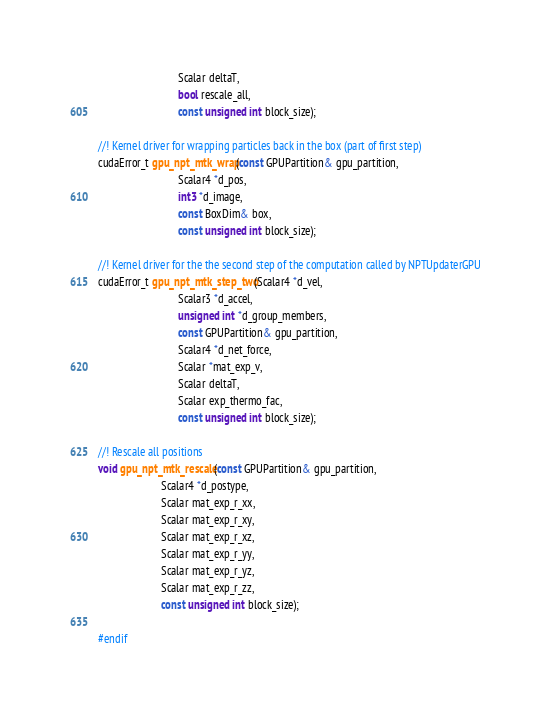<code> <loc_0><loc_0><loc_500><loc_500><_Cuda_>                             Scalar deltaT,
                             bool rescale_all,
                             const unsigned int block_size);

//! Kernel driver for wrapping particles back in the box (part of first step)
cudaError_t gpu_npt_mtk_wrap(const GPUPartition& gpu_partition,
                             Scalar4 *d_pos,
                             int3 *d_image,
                             const BoxDim& box,
                             const unsigned int block_size);

//! Kernel driver for the the second step of the computation called by NPTUpdaterGPU
cudaError_t gpu_npt_mtk_step_two(Scalar4 *d_vel,
                             Scalar3 *d_accel,
                             unsigned int *d_group_members,
                             const GPUPartition& gpu_partition,
                             Scalar4 *d_net_force,
                             Scalar *mat_exp_v,
                             Scalar deltaT,
                             Scalar exp_thermo_fac,
                             const unsigned int block_size);

//! Rescale all positions
void gpu_npt_mtk_rescale(const GPUPartition& gpu_partition,
                       Scalar4 *d_postype,
                       Scalar mat_exp_r_xx,
                       Scalar mat_exp_r_xy,
                       Scalar mat_exp_r_xz,
                       Scalar mat_exp_r_yy,
                       Scalar mat_exp_r_yz,
                       Scalar mat_exp_r_zz,
                       const unsigned int block_size);

#endif
</code> 